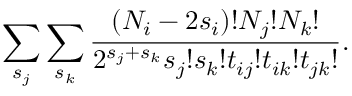<formula> <loc_0><loc_0><loc_500><loc_500>\sum _ { s _ { j } } \sum _ { s _ { k } } \frac { ( N _ { i } - 2 s _ { i } ) ! N _ { j } ! N _ { k } ! } { 2 ^ { s _ { j } + s _ { k } } s _ { j } ! s _ { k } ! t _ { i j } ! t _ { i k } ! t _ { j k } ! } .</formula> 